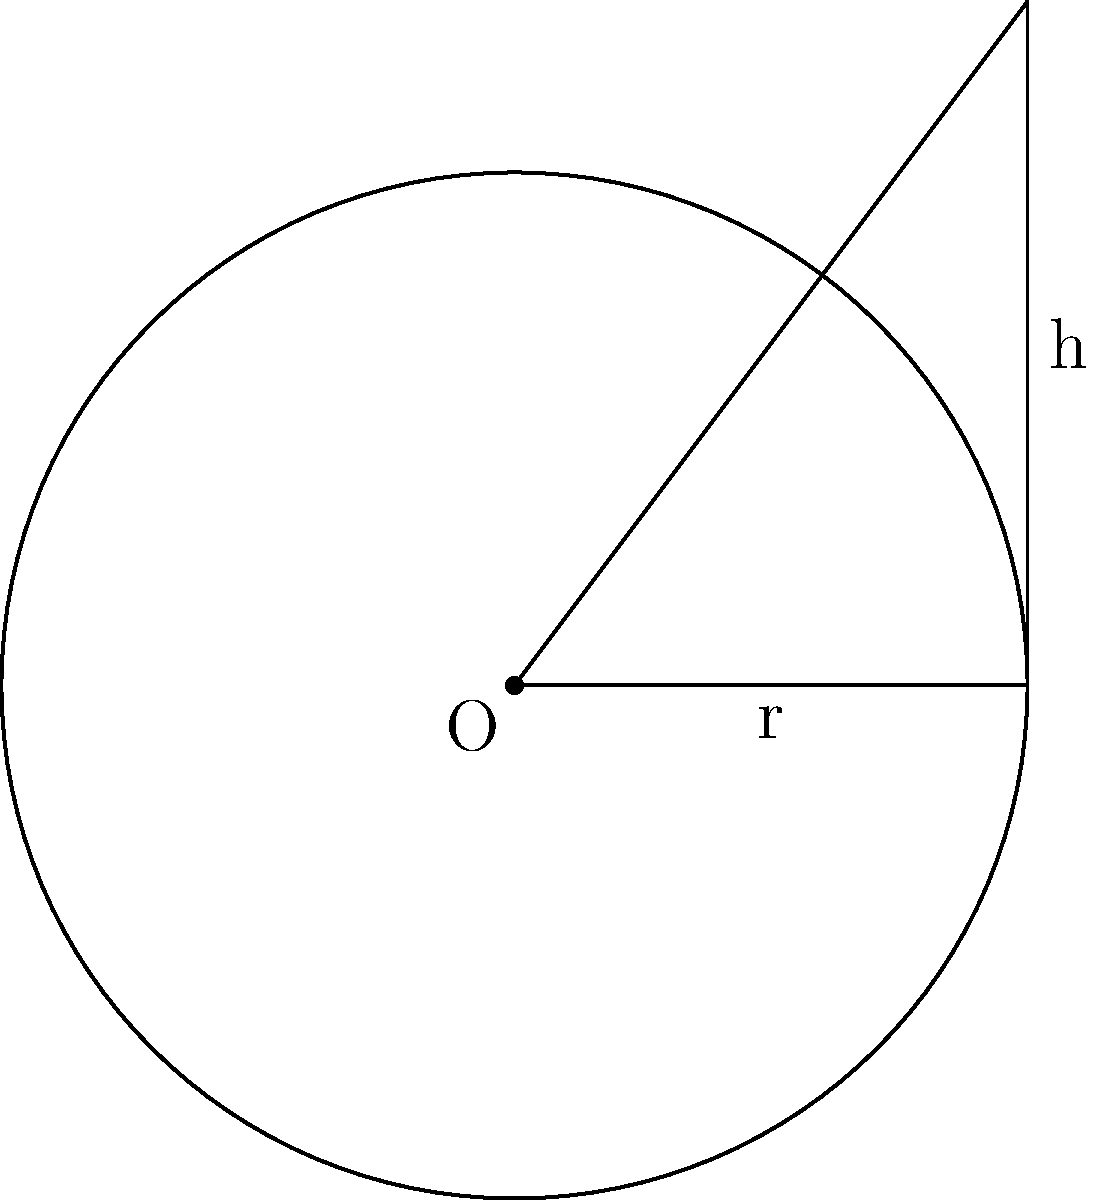As a travel blogger visiting a circus in Rio de Janeiro, you notice a unique conical tent. The circular base of the tent has a radius of 15 meters, and the height of the tent is 20 meters. What is the volume of this circus tent in cubic meters? To find the volume of the conical circus tent, we need to use the formula for the volume of a cone:

$$V = \frac{1}{3}\pi r^2 h$$

Where:
$V$ = volume
$r$ = radius of the base
$h$ = height of the cone

Given:
$r = 15$ meters
$h = 20$ meters

Let's substitute these values into the formula:

$$V = \frac{1}{3}\pi (15\text{ m})^2 (20\text{ m})$$

Now, let's calculate step by step:

1) First, calculate $r^2$:
   $15^2 = 225$

2) Multiply by $\pi$:
   $225\pi$

3) Multiply by the height:
   $225\pi \times 20 = 4500\pi$

4) Multiply by $\frac{1}{3}$:
   $\frac{1}{3} \times 4500\pi = 1500\pi$

Therefore, the volume of the conical circus tent is $1500\pi$ cubic meters.

To get a numerical approximation:
$1500\pi \approx 4712.39$ cubic meters
Answer: $1500\pi$ cubic meters 